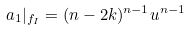Convert formula to latex. <formula><loc_0><loc_0><loc_500><loc_500>a _ { 1 } | _ { f _ { I } } = ( n - 2 k ) ^ { n - 1 } u ^ { n - 1 }</formula> 